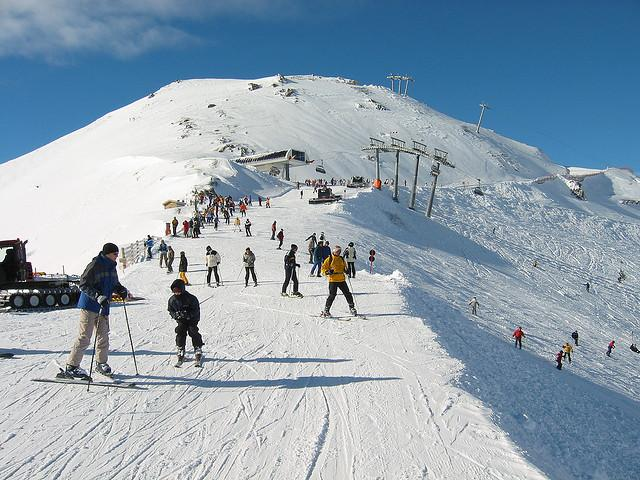What sort of skill is required at the slope in the foreground here? skiing 